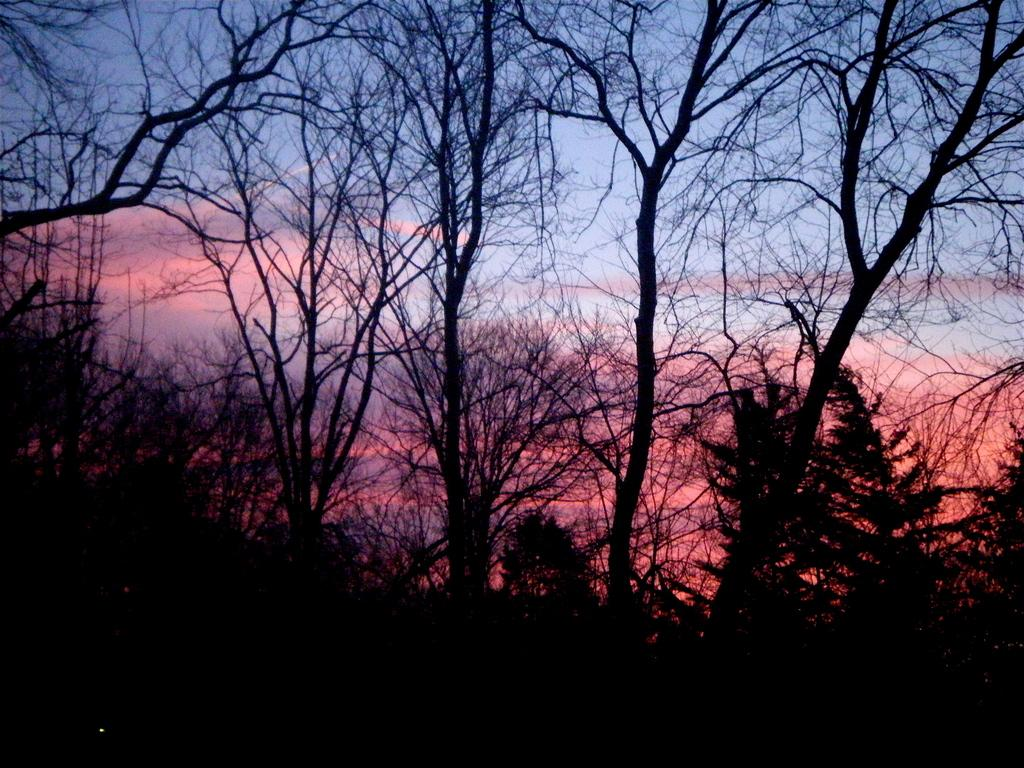What is the main feature of the image? There are many trees in the image. What can be seen in the sky in the image? There are orange clouds visible in the sky. Is the sky the only visible element in the image? No, the sky is not the only visible element; there are also many trees. What type of record is being played by the cactus in the image? There is no record or cactus present in the image; it features many trees and orange clouds in the sky. 